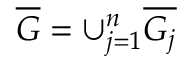Convert formula to latex. <formula><loc_0><loc_0><loc_500><loc_500>\overline { G } = \cup _ { j = 1 } ^ { n } \overline { { G _ { j } } }</formula> 